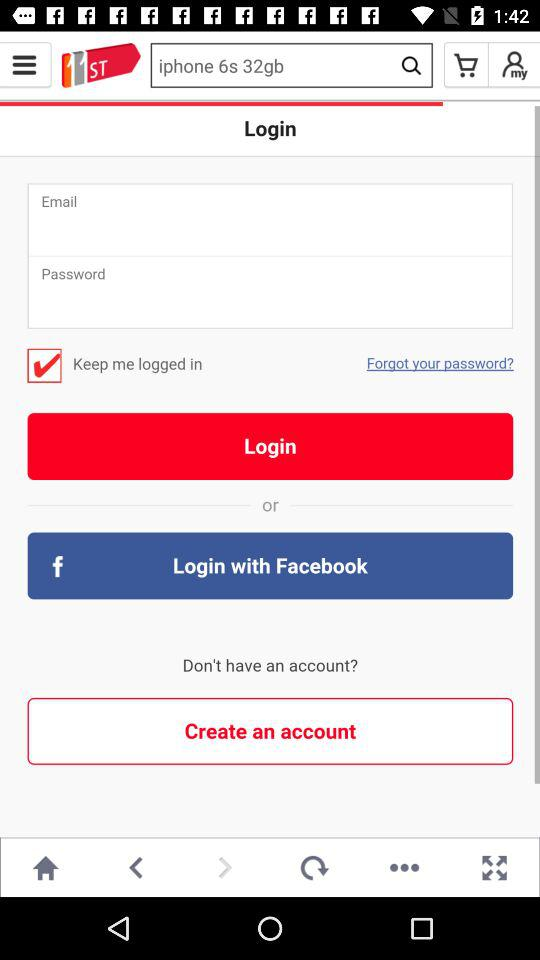What number is associated with the word "Shocking"? The number that is associated with the word "Shocking" is 11. 